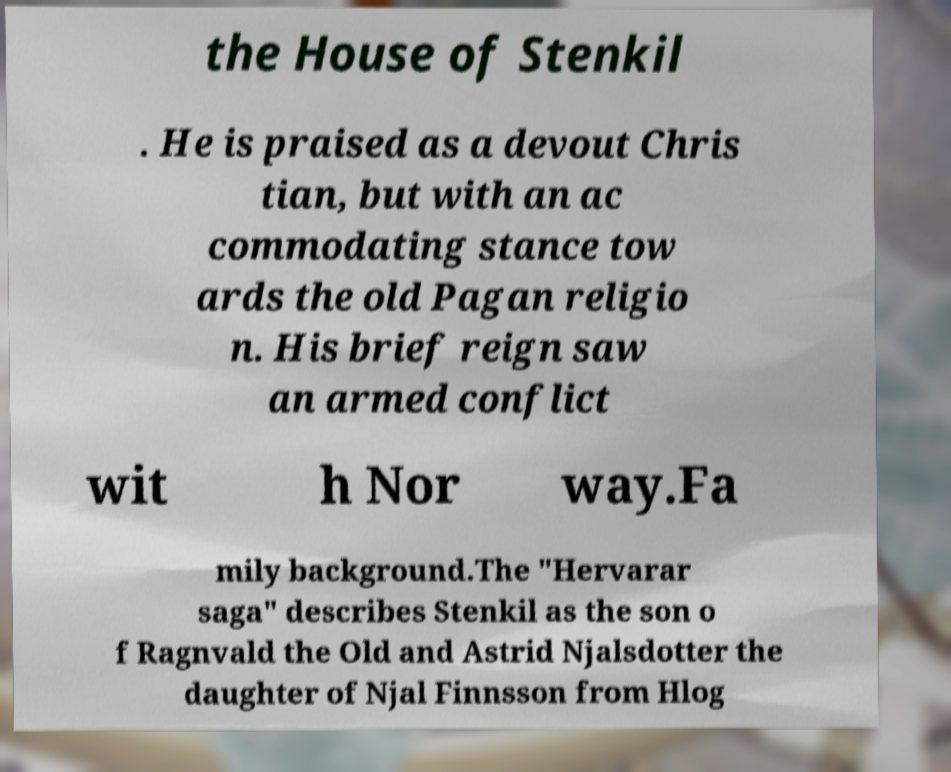Can you accurately transcribe the text from the provided image for me? the House of Stenkil . He is praised as a devout Chris tian, but with an ac commodating stance tow ards the old Pagan religio n. His brief reign saw an armed conflict wit h Nor way.Fa mily background.The "Hervarar saga" describes Stenkil as the son o f Ragnvald the Old and Astrid Njalsdotter the daughter of Njal Finnsson from Hlog 